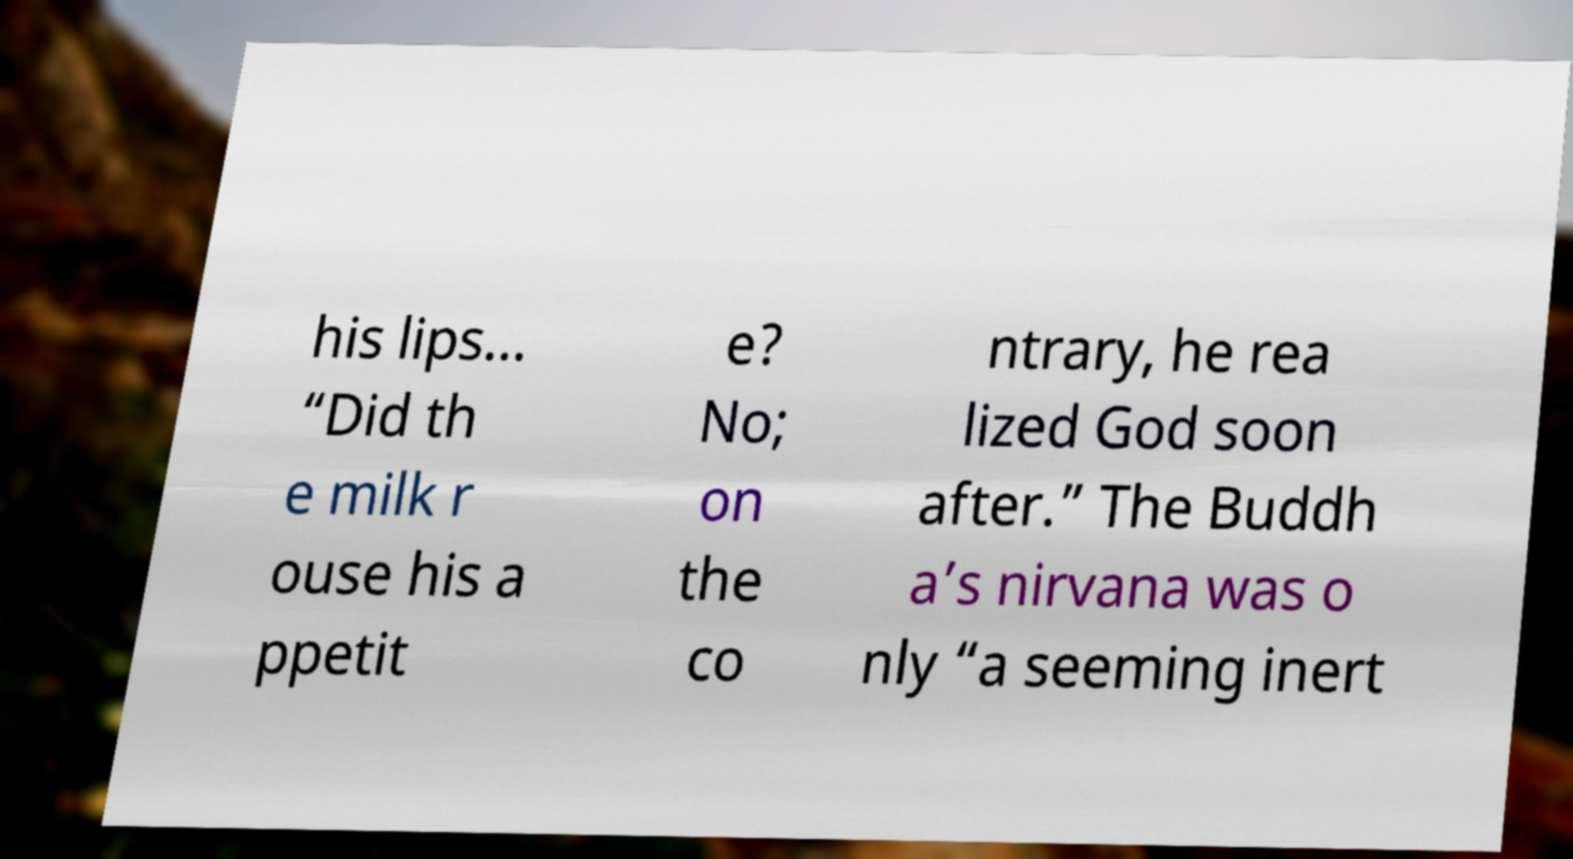Could you extract and type out the text from this image? his lips... “Did th e milk r ouse his a ppetit e? No; on the co ntrary, he rea lized God soon after.” The Buddh a’s nirvana was o nly “a seeming inert 